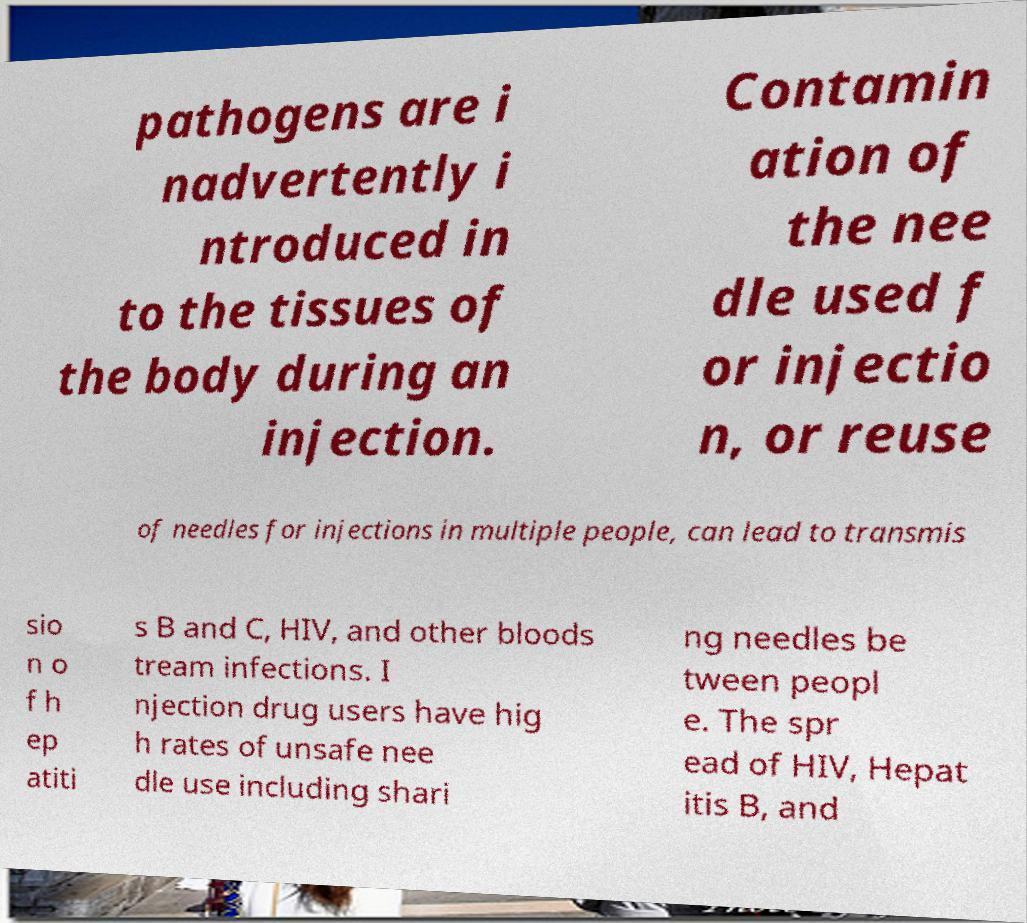Can you read and provide the text displayed in the image?This photo seems to have some interesting text. Can you extract and type it out for me? pathogens are i nadvertently i ntroduced in to the tissues of the body during an injection. Contamin ation of the nee dle used f or injectio n, or reuse of needles for injections in multiple people, can lead to transmis sio n o f h ep atiti s B and C, HIV, and other bloods tream infections. I njection drug users have hig h rates of unsafe nee dle use including shari ng needles be tween peopl e. The spr ead of HIV, Hepat itis B, and 